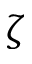<formula> <loc_0><loc_0><loc_500><loc_500>\zeta</formula> 